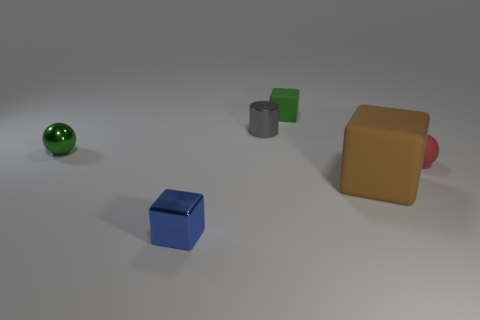Subtract 1 blocks. How many blocks are left? 2 Add 1 red matte balls. How many objects exist? 7 Subtract all spheres. How many objects are left? 4 Subtract all blue balls. Subtract all small cubes. How many objects are left? 4 Add 6 cubes. How many cubes are left? 9 Add 5 gray metallic cylinders. How many gray metallic cylinders exist? 6 Subtract 1 red spheres. How many objects are left? 5 